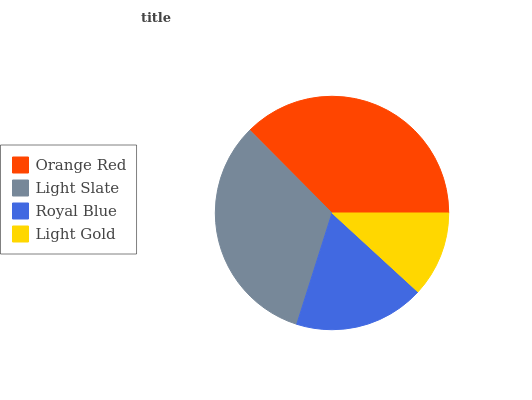Is Light Gold the minimum?
Answer yes or no. Yes. Is Orange Red the maximum?
Answer yes or no. Yes. Is Light Slate the minimum?
Answer yes or no. No. Is Light Slate the maximum?
Answer yes or no. No. Is Orange Red greater than Light Slate?
Answer yes or no. Yes. Is Light Slate less than Orange Red?
Answer yes or no. Yes. Is Light Slate greater than Orange Red?
Answer yes or no. No. Is Orange Red less than Light Slate?
Answer yes or no. No. Is Light Slate the high median?
Answer yes or no. Yes. Is Royal Blue the low median?
Answer yes or no. Yes. Is Orange Red the high median?
Answer yes or no. No. Is Light Gold the low median?
Answer yes or no. No. 